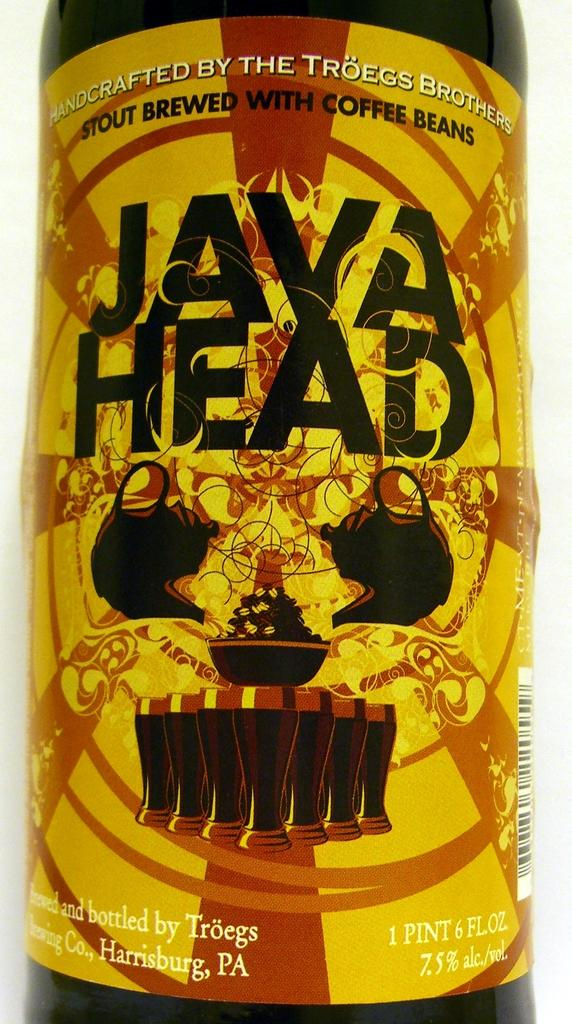What is present on the label in the image? The label contains letters, pictures, and a barcode. What is the label attached to in the image? The label is attached to an object. Can you see any branches growing from the label in the image? There are no branches growing from the label in the image. Is the label suitable for a beginner to understand in the image? The image does not provide information about the label's suitability for a beginner to understand. Is there a carriage visible in the image? There is no carriage present in the image. 